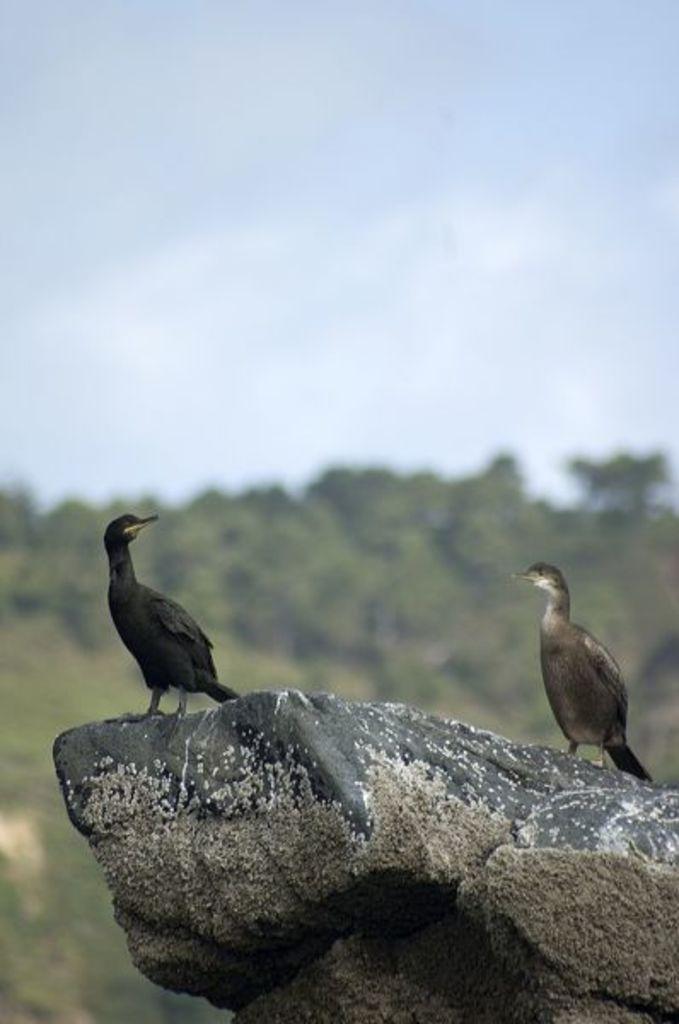How would you summarize this image in a sentence or two? In the image in the center, we can see one stone. On the stone, we can see two birds, which are in black and white color. In the background we can see the sky, clouds and trees. 